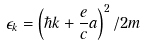Convert formula to latex. <formula><loc_0><loc_0><loc_500><loc_500>\epsilon _ { k } = \left ( \hbar { k } + \frac { e } { c } { a } \right ) ^ { 2 } / 2 m</formula> 